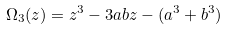<formula> <loc_0><loc_0><loc_500><loc_500>\Omega _ { 3 } ( z ) = z ^ { 3 } - 3 a b z - ( a ^ { 3 } + b ^ { 3 } )</formula> 